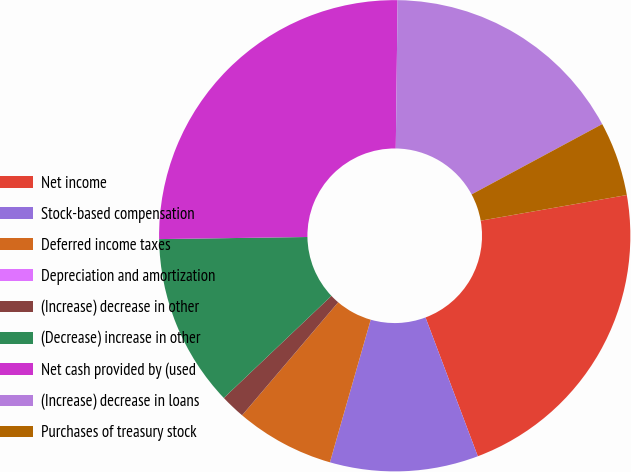Convert chart. <chart><loc_0><loc_0><loc_500><loc_500><pie_chart><fcel>Net income<fcel>Stock-based compensation<fcel>Deferred income taxes<fcel>Depreciation and amortization<fcel>(Increase) decrease in other<fcel>(Decrease) increase in other<fcel>Net cash provided by (used<fcel>(Increase) decrease in loans<fcel>Purchases of treasury stock<nl><fcel>22.03%<fcel>10.17%<fcel>6.78%<fcel>0.0%<fcel>1.7%<fcel>11.86%<fcel>25.42%<fcel>16.95%<fcel>5.09%<nl></chart> 